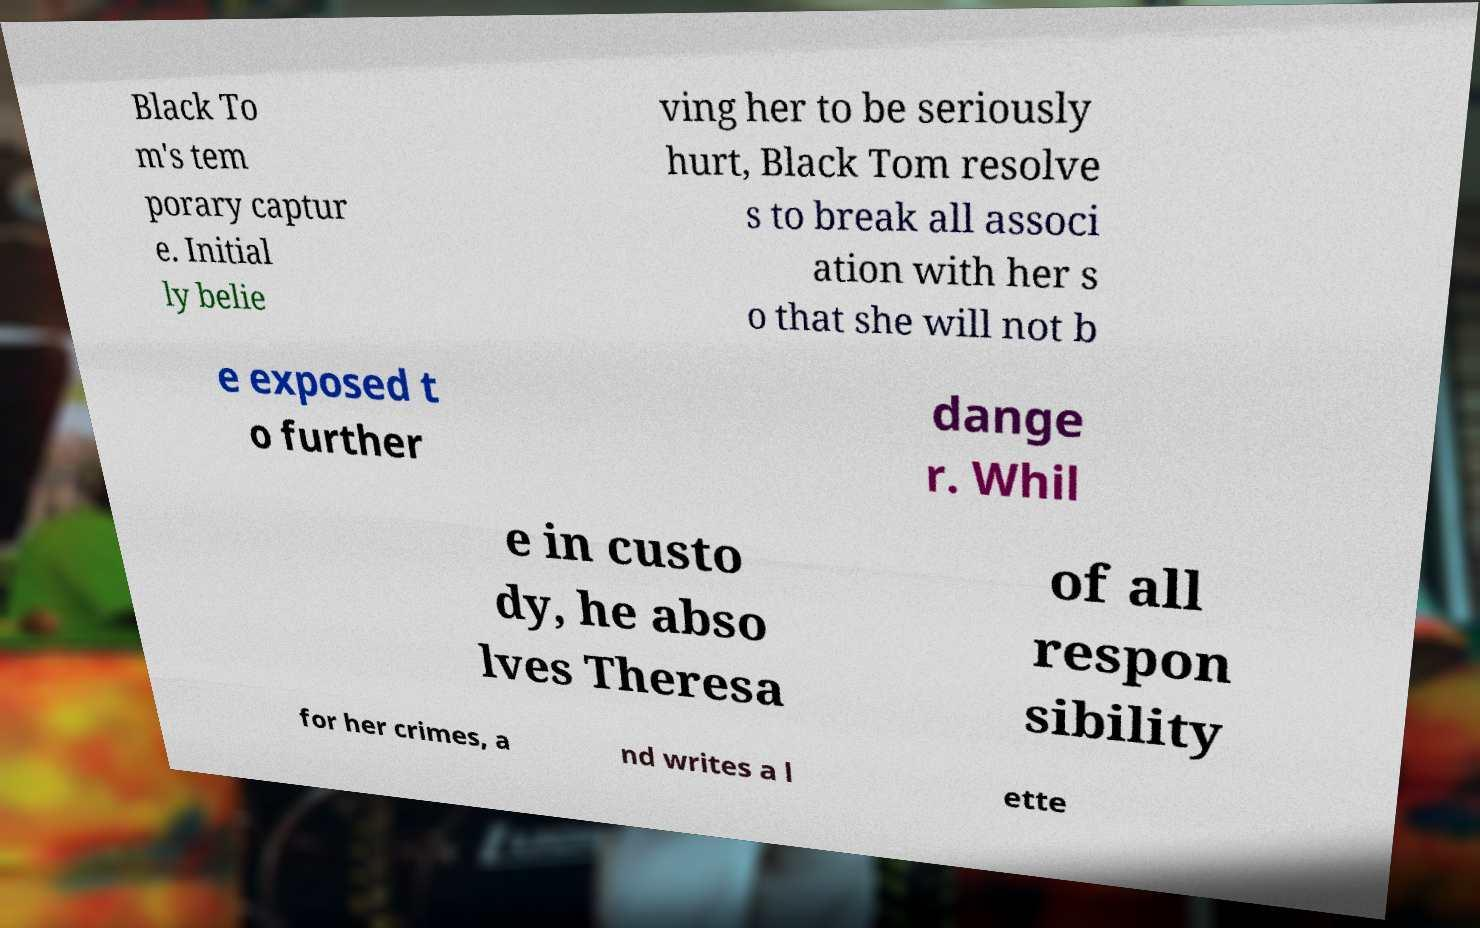Please identify and transcribe the text found in this image. Black To m's tem porary captur e. Initial ly belie ving her to be seriously hurt, Black Tom resolve s to break all associ ation with her s o that she will not b e exposed t o further dange r. Whil e in custo dy, he abso lves Theresa of all respon sibility for her crimes, a nd writes a l ette 